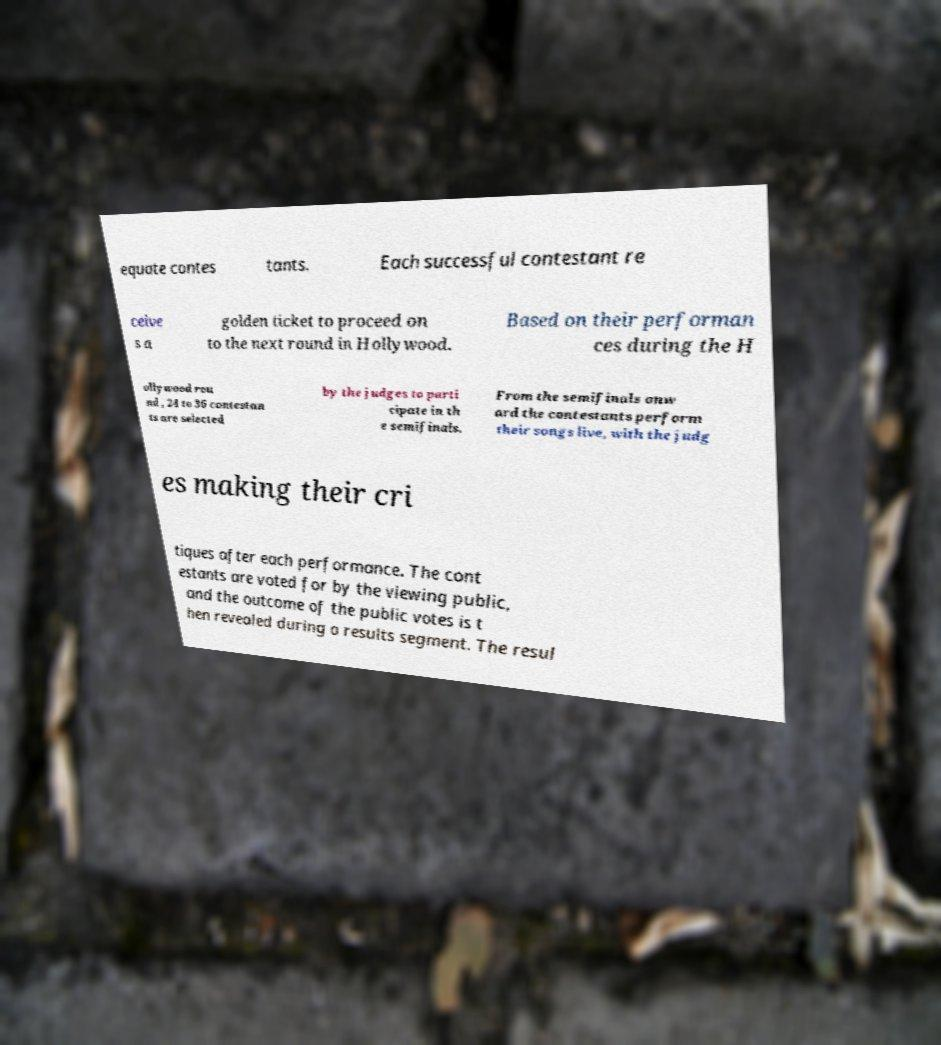What messages or text are displayed in this image? I need them in a readable, typed format. equate contes tants. Each successful contestant re ceive s a golden ticket to proceed on to the next round in Hollywood. Based on their performan ces during the H ollywood rou nd , 24 to 36 contestan ts are selected by the judges to parti cipate in th e semifinals. From the semifinals onw ard the contestants perform their songs live, with the judg es making their cri tiques after each performance. The cont estants are voted for by the viewing public, and the outcome of the public votes is t hen revealed during a results segment. The resul 